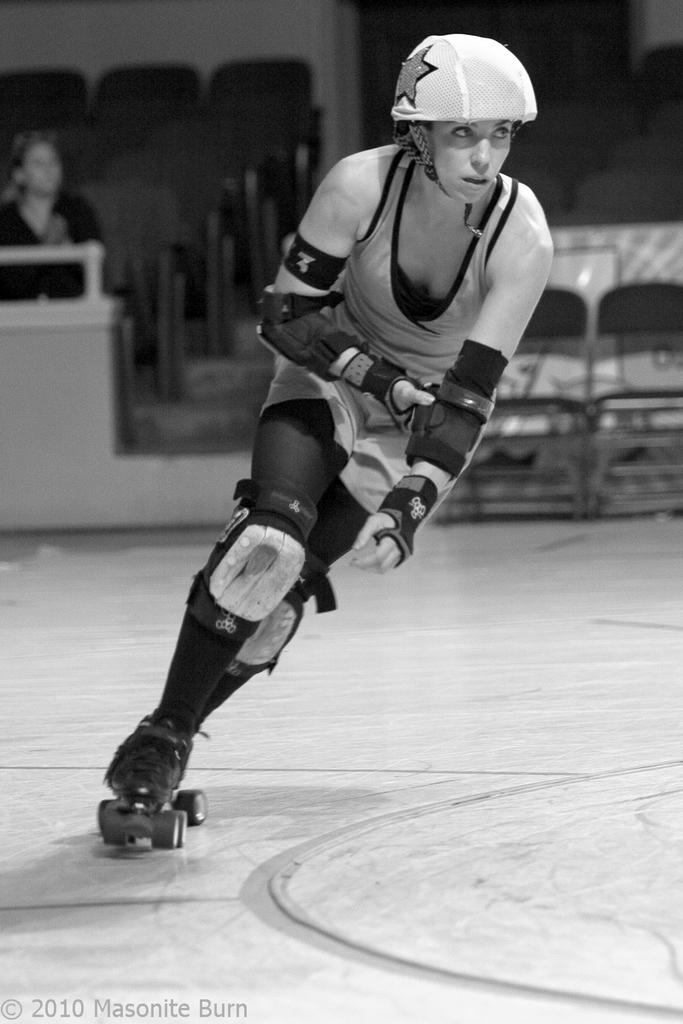What activity is the person in the image engaged in? The person is doing skating in the image. What can be seen behind the person while they are skating? There is a group of chairs behind the person. What is visible in the background of the image? There is a wall visible in the image. Are there any other people present in the image? Yes, there is another person in the image. What type of bell can be heard ringing in the image? There is no bell present in the image, and therefore no sound can be heard. 